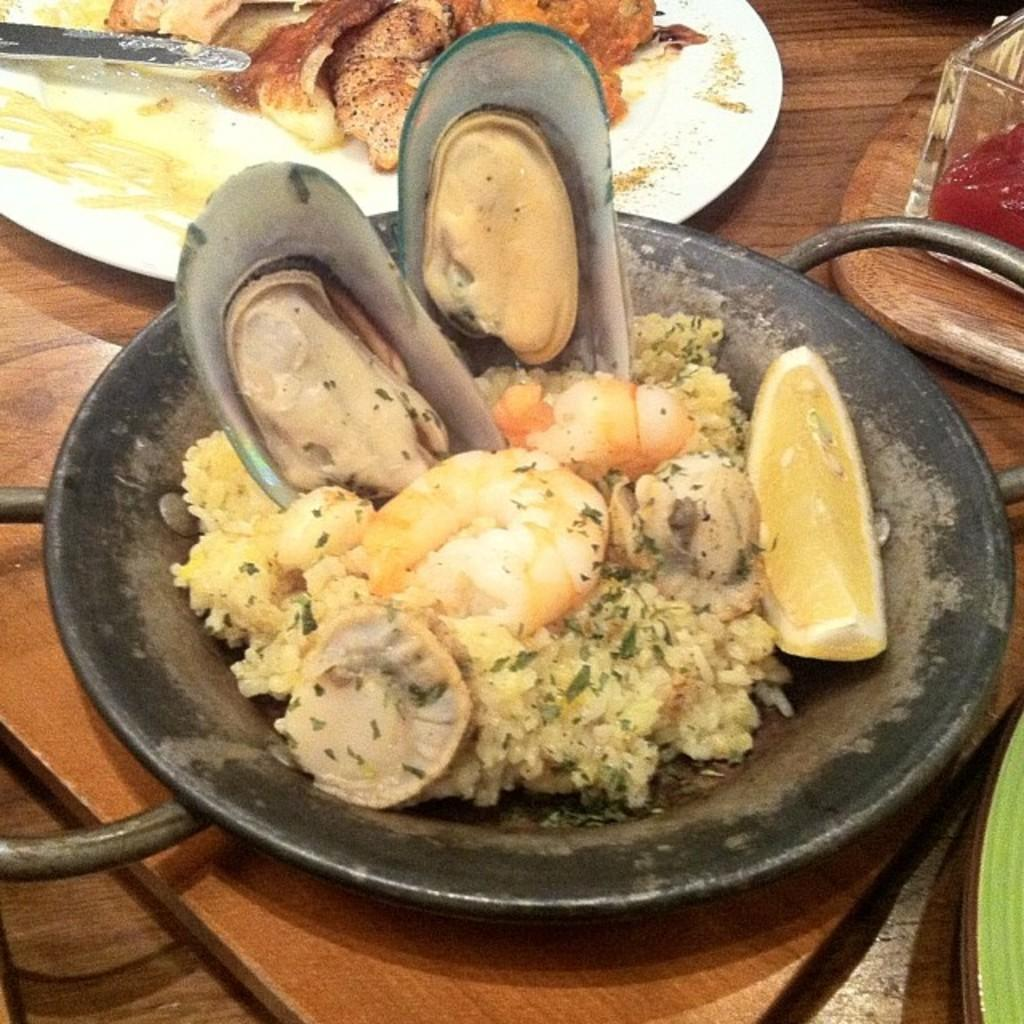What is on the table in the image? There is a plate and a dish on the table. What is the purpose of the plate and dish? The plate and dish contain food. What type of care is being provided to the pot in the image? There is no pot present in the image, so no care is being provided to a pot. 